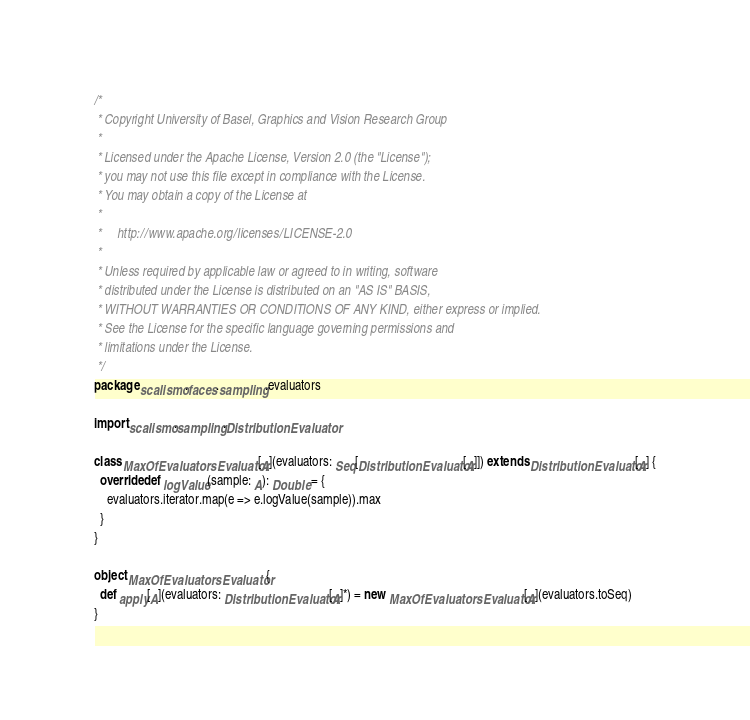Convert code to text. <code><loc_0><loc_0><loc_500><loc_500><_Scala_>/*
 * Copyright University of Basel, Graphics and Vision Research Group
 *
 * Licensed under the Apache License, Version 2.0 (the "License");
 * you may not use this file except in compliance with the License.
 * You may obtain a copy of the License at
 *
 *     http://www.apache.org/licenses/LICENSE-2.0
 *
 * Unless required by applicable law or agreed to in writing, software
 * distributed under the License is distributed on an "AS IS" BASIS,
 * WITHOUT WARRANTIES OR CONDITIONS OF ANY KIND, either express or implied.
 * See the License for the specific language governing permissions and
 * limitations under the License.
 */
package scalismo.faces.sampling.evaluators

import scalismo.sampling.DistributionEvaluator

class MaxOfEvaluatorsEvaluator[A](evaluators: Seq[DistributionEvaluator[A]]) extends DistributionEvaluator[A] {
  override def logValue(sample: A): Double = {
    evaluators.iterator.map(e => e.logValue(sample)).max
  }
}

object MaxOfEvaluatorsEvaluator {
  def apply[A](evaluators: DistributionEvaluator[A]*) = new MaxOfEvaluatorsEvaluator[A](evaluators.toSeq)
}</code> 